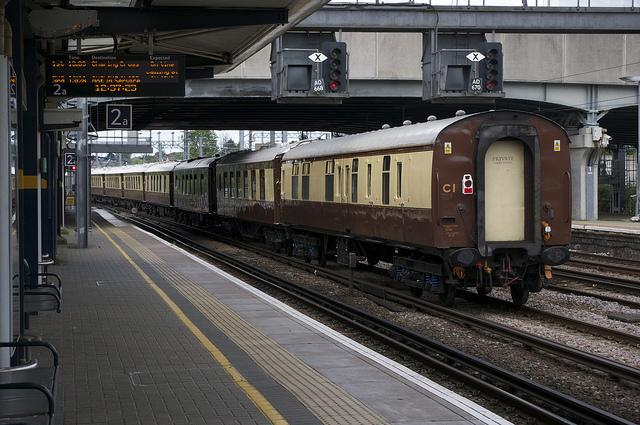What are the passengers told to wait behind?

Choices:
A) yellow line
B) glass door
C) velvet rope
D) pylon yellow line 